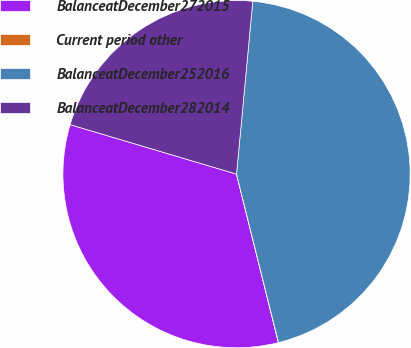<chart> <loc_0><loc_0><loc_500><loc_500><pie_chart><fcel>BalanceatDecember272015<fcel>Current period other<fcel>BalanceatDecember252016<fcel>BalanceatDecember282014<nl><fcel>33.48%<fcel>0.01%<fcel>44.62%<fcel>21.89%<nl></chart> 